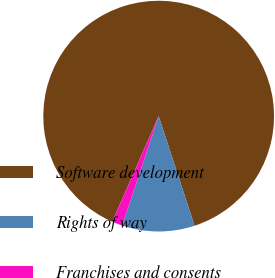Convert chart to OTSL. <chart><loc_0><loc_0><loc_500><loc_500><pie_chart><fcel>Software development<fcel>Rights of way<fcel>Franchises and consents<nl><fcel>88.37%<fcel>10.16%<fcel>1.47%<nl></chart> 